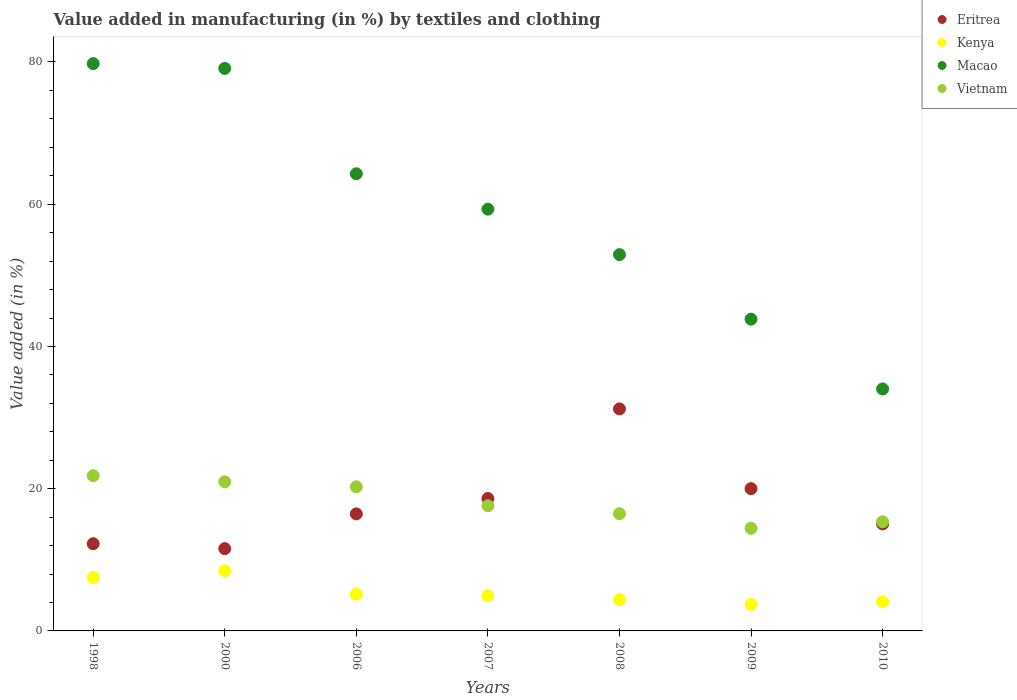How many different coloured dotlines are there?
Offer a terse response. 4. Is the number of dotlines equal to the number of legend labels?
Provide a succinct answer. Yes. What is the percentage of value added in manufacturing by textiles and clothing in Kenya in 2008?
Give a very brief answer. 4.4. Across all years, what is the maximum percentage of value added in manufacturing by textiles and clothing in Eritrea?
Give a very brief answer. 31.22. Across all years, what is the minimum percentage of value added in manufacturing by textiles and clothing in Macao?
Provide a short and direct response. 34.02. In which year was the percentage of value added in manufacturing by textiles and clothing in Vietnam maximum?
Your answer should be very brief. 1998. In which year was the percentage of value added in manufacturing by textiles and clothing in Kenya minimum?
Keep it short and to the point. 2009. What is the total percentage of value added in manufacturing by textiles and clothing in Kenya in the graph?
Your answer should be compact. 38.33. What is the difference between the percentage of value added in manufacturing by textiles and clothing in Eritrea in 2006 and that in 2007?
Your response must be concise. -2.16. What is the difference between the percentage of value added in manufacturing by textiles and clothing in Vietnam in 2006 and the percentage of value added in manufacturing by textiles and clothing in Macao in 2009?
Offer a terse response. -23.58. What is the average percentage of value added in manufacturing by textiles and clothing in Kenya per year?
Ensure brevity in your answer.  5.48. In the year 2008, what is the difference between the percentage of value added in manufacturing by textiles and clothing in Kenya and percentage of value added in manufacturing by textiles and clothing in Vietnam?
Offer a terse response. -12.08. In how many years, is the percentage of value added in manufacturing by textiles and clothing in Eritrea greater than 60 %?
Provide a short and direct response. 0. What is the ratio of the percentage of value added in manufacturing by textiles and clothing in Vietnam in 2000 to that in 2006?
Give a very brief answer. 1.03. Is the percentage of value added in manufacturing by textiles and clothing in Eritrea in 2006 less than that in 2008?
Provide a succinct answer. Yes. Is the difference between the percentage of value added in manufacturing by textiles and clothing in Kenya in 1998 and 2009 greater than the difference between the percentage of value added in manufacturing by textiles and clothing in Vietnam in 1998 and 2009?
Offer a very short reply. No. What is the difference between the highest and the second highest percentage of value added in manufacturing by textiles and clothing in Kenya?
Your answer should be compact. 0.94. What is the difference between the highest and the lowest percentage of value added in manufacturing by textiles and clothing in Macao?
Ensure brevity in your answer.  45.75. In how many years, is the percentage of value added in manufacturing by textiles and clothing in Eritrea greater than the average percentage of value added in manufacturing by textiles and clothing in Eritrea taken over all years?
Make the answer very short. 3. Is it the case that in every year, the sum of the percentage of value added in manufacturing by textiles and clothing in Vietnam and percentage of value added in manufacturing by textiles and clothing in Kenya  is greater than the sum of percentage of value added in manufacturing by textiles and clothing in Macao and percentage of value added in manufacturing by textiles and clothing in Eritrea?
Make the answer very short. No. Is it the case that in every year, the sum of the percentage of value added in manufacturing by textiles and clothing in Eritrea and percentage of value added in manufacturing by textiles and clothing in Macao  is greater than the percentage of value added in manufacturing by textiles and clothing in Vietnam?
Your response must be concise. Yes. How many dotlines are there?
Give a very brief answer. 4. How many legend labels are there?
Offer a terse response. 4. How are the legend labels stacked?
Offer a very short reply. Vertical. What is the title of the graph?
Ensure brevity in your answer.  Value added in manufacturing (in %) by textiles and clothing. Does "Germany" appear as one of the legend labels in the graph?
Ensure brevity in your answer.  No. What is the label or title of the X-axis?
Your answer should be very brief. Years. What is the label or title of the Y-axis?
Offer a very short reply. Value added (in %). What is the Value added (in %) of Eritrea in 1998?
Keep it short and to the point. 12.26. What is the Value added (in %) in Kenya in 1998?
Make the answer very short. 7.53. What is the Value added (in %) in Macao in 1998?
Provide a succinct answer. 79.77. What is the Value added (in %) of Vietnam in 1998?
Your answer should be compact. 21.83. What is the Value added (in %) in Eritrea in 2000?
Offer a terse response. 11.57. What is the Value added (in %) of Kenya in 2000?
Ensure brevity in your answer.  8.47. What is the Value added (in %) in Macao in 2000?
Offer a very short reply. 79.1. What is the Value added (in %) in Vietnam in 2000?
Ensure brevity in your answer.  20.96. What is the Value added (in %) of Eritrea in 2006?
Your answer should be compact. 16.46. What is the Value added (in %) in Kenya in 2006?
Your answer should be very brief. 5.18. What is the Value added (in %) in Macao in 2006?
Offer a very short reply. 64.28. What is the Value added (in %) in Vietnam in 2006?
Offer a terse response. 20.26. What is the Value added (in %) of Eritrea in 2007?
Offer a terse response. 18.62. What is the Value added (in %) in Kenya in 2007?
Provide a succinct answer. 4.93. What is the Value added (in %) in Macao in 2007?
Give a very brief answer. 59.3. What is the Value added (in %) in Vietnam in 2007?
Make the answer very short. 17.59. What is the Value added (in %) in Eritrea in 2008?
Provide a short and direct response. 31.22. What is the Value added (in %) in Kenya in 2008?
Your response must be concise. 4.4. What is the Value added (in %) of Macao in 2008?
Offer a very short reply. 52.92. What is the Value added (in %) in Vietnam in 2008?
Give a very brief answer. 16.48. What is the Value added (in %) of Eritrea in 2009?
Offer a very short reply. 20.01. What is the Value added (in %) of Kenya in 2009?
Give a very brief answer. 3.72. What is the Value added (in %) of Macao in 2009?
Ensure brevity in your answer.  43.84. What is the Value added (in %) of Vietnam in 2009?
Provide a succinct answer. 14.43. What is the Value added (in %) in Eritrea in 2010?
Provide a succinct answer. 15.04. What is the Value added (in %) in Kenya in 2010?
Provide a succinct answer. 4.1. What is the Value added (in %) of Macao in 2010?
Provide a succinct answer. 34.02. What is the Value added (in %) of Vietnam in 2010?
Provide a short and direct response. 15.35. Across all years, what is the maximum Value added (in %) of Eritrea?
Give a very brief answer. 31.22. Across all years, what is the maximum Value added (in %) in Kenya?
Make the answer very short. 8.47. Across all years, what is the maximum Value added (in %) in Macao?
Your answer should be compact. 79.77. Across all years, what is the maximum Value added (in %) in Vietnam?
Give a very brief answer. 21.83. Across all years, what is the minimum Value added (in %) in Eritrea?
Your answer should be very brief. 11.57. Across all years, what is the minimum Value added (in %) in Kenya?
Offer a very short reply. 3.72. Across all years, what is the minimum Value added (in %) in Macao?
Your answer should be very brief. 34.02. Across all years, what is the minimum Value added (in %) of Vietnam?
Offer a very short reply. 14.43. What is the total Value added (in %) in Eritrea in the graph?
Give a very brief answer. 125.17. What is the total Value added (in %) in Kenya in the graph?
Keep it short and to the point. 38.33. What is the total Value added (in %) of Macao in the graph?
Make the answer very short. 413.23. What is the total Value added (in %) in Vietnam in the graph?
Provide a succinct answer. 126.9. What is the difference between the Value added (in %) of Eritrea in 1998 and that in 2000?
Give a very brief answer. 0.69. What is the difference between the Value added (in %) of Kenya in 1998 and that in 2000?
Your answer should be compact. -0.94. What is the difference between the Value added (in %) of Macao in 1998 and that in 2000?
Keep it short and to the point. 0.67. What is the difference between the Value added (in %) in Vietnam in 1998 and that in 2000?
Your answer should be compact. 0.86. What is the difference between the Value added (in %) in Eritrea in 1998 and that in 2006?
Give a very brief answer. -4.19. What is the difference between the Value added (in %) in Kenya in 1998 and that in 2006?
Your answer should be compact. 2.35. What is the difference between the Value added (in %) in Macao in 1998 and that in 2006?
Offer a terse response. 15.49. What is the difference between the Value added (in %) of Vietnam in 1998 and that in 2006?
Ensure brevity in your answer.  1.57. What is the difference between the Value added (in %) in Eritrea in 1998 and that in 2007?
Ensure brevity in your answer.  -6.36. What is the difference between the Value added (in %) of Kenya in 1998 and that in 2007?
Keep it short and to the point. 2.6. What is the difference between the Value added (in %) in Macao in 1998 and that in 2007?
Offer a terse response. 20.47. What is the difference between the Value added (in %) in Vietnam in 1998 and that in 2007?
Provide a succinct answer. 4.23. What is the difference between the Value added (in %) of Eritrea in 1998 and that in 2008?
Provide a short and direct response. -18.95. What is the difference between the Value added (in %) of Kenya in 1998 and that in 2008?
Provide a succinct answer. 3.13. What is the difference between the Value added (in %) in Macao in 1998 and that in 2008?
Provide a short and direct response. 26.86. What is the difference between the Value added (in %) of Vietnam in 1998 and that in 2008?
Provide a short and direct response. 5.34. What is the difference between the Value added (in %) of Eritrea in 1998 and that in 2009?
Your answer should be compact. -7.74. What is the difference between the Value added (in %) of Kenya in 1998 and that in 2009?
Provide a short and direct response. 3.81. What is the difference between the Value added (in %) of Macao in 1998 and that in 2009?
Your answer should be very brief. 35.93. What is the difference between the Value added (in %) in Vietnam in 1998 and that in 2009?
Ensure brevity in your answer.  7.4. What is the difference between the Value added (in %) in Eritrea in 1998 and that in 2010?
Provide a succinct answer. -2.78. What is the difference between the Value added (in %) in Kenya in 1998 and that in 2010?
Your response must be concise. 3.43. What is the difference between the Value added (in %) of Macao in 1998 and that in 2010?
Your answer should be compact. 45.75. What is the difference between the Value added (in %) in Vietnam in 1998 and that in 2010?
Your answer should be compact. 6.48. What is the difference between the Value added (in %) in Eritrea in 2000 and that in 2006?
Make the answer very short. -4.89. What is the difference between the Value added (in %) of Kenya in 2000 and that in 2006?
Provide a succinct answer. 3.29. What is the difference between the Value added (in %) of Macao in 2000 and that in 2006?
Make the answer very short. 14.82. What is the difference between the Value added (in %) in Vietnam in 2000 and that in 2006?
Ensure brevity in your answer.  0.7. What is the difference between the Value added (in %) in Eritrea in 2000 and that in 2007?
Your answer should be very brief. -7.05. What is the difference between the Value added (in %) in Kenya in 2000 and that in 2007?
Offer a terse response. 3.53. What is the difference between the Value added (in %) of Macao in 2000 and that in 2007?
Your answer should be compact. 19.79. What is the difference between the Value added (in %) in Vietnam in 2000 and that in 2007?
Your answer should be compact. 3.37. What is the difference between the Value added (in %) of Eritrea in 2000 and that in 2008?
Make the answer very short. -19.65. What is the difference between the Value added (in %) of Kenya in 2000 and that in 2008?
Your answer should be compact. 4.06. What is the difference between the Value added (in %) of Macao in 2000 and that in 2008?
Give a very brief answer. 26.18. What is the difference between the Value added (in %) in Vietnam in 2000 and that in 2008?
Ensure brevity in your answer.  4.48. What is the difference between the Value added (in %) of Eritrea in 2000 and that in 2009?
Give a very brief answer. -8.44. What is the difference between the Value added (in %) in Kenya in 2000 and that in 2009?
Your answer should be very brief. 4.74. What is the difference between the Value added (in %) of Macao in 2000 and that in 2009?
Your response must be concise. 35.26. What is the difference between the Value added (in %) of Vietnam in 2000 and that in 2009?
Offer a very short reply. 6.54. What is the difference between the Value added (in %) in Eritrea in 2000 and that in 2010?
Your answer should be very brief. -3.47. What is the difference between the Value added (in %) in Kenya in 2000 and that in 2010?
Provide a short and direct response. 4.36. What is the difference between the Value added (in %) in Macao in 2000 and that in 2010?
Give a very brief answer. 45.07. What is the difference between the Value added (in %) in Vietnam in 2000 and that in 2010?
Offer a terse response. 5.61. What is the difference between the Value added (in %) of Eritrea in 2006 and that in 2007?
Make the answer very short. -2.16. What is the difference between the Value added (in %) of Kenya in 2006 and that in 2007?
Your answer should be very brief. 0.24. What is the difference between the Value added (in %) in Macao in 2006 and that in 2007?
Your answer should be very brief. 4.98. What is the difference between the Value added (in %) in Vietnam in 2006 and that in 2007?
Keep it short and to the point. 2.67. What is the difference between the Value added (in %) in Eritrea in 2006 and that in 2008?
Your answer should be compact. -14.76. What is the difference between the Value added (in %) in Kenya in 2006 and that in 2008?
Offer a very short reply. 0.77. What is the difference between the Value added (in %) in Macao in 2006 and that in 2008?
Provide a short and direct response. 11.37. What is the difference between the Value added (in %) in Vietnam in 2006 and that in 2008?
Provide a succinct answer. 3.78. What is the difference between the Value added (in %) of Eritrea in 2006 and that in 2009?
Your answer should be compact. -3.55. What is the difference between the Value added (in %) of Kenya in 2006 and that in 2009?
Your answer should be very brief. 1.45. What is the difference between the Value added (in %) in Macao in 2006 and that in 2009?
Keep it short and to the point. 20.44. What is the difference between the Value added (in %) in Vietnam in 2006 and that in 2009?
Keep it short and to the point. 5.83. What is the difference between the Value added (in %) of Eritrea in 2006 and that in 2010?
Make the answer very short. 1.41. What is the difference between the Value added (in %) of Kenya in 2006 and that in 2010?
Your answer should be compact. 1.07. What is the difference between the Value added (in %) in Macao in 2006 and that in 2010?
Offer a terse response. 30.26. What is the difference between the Value added (in %) in Vietnam in 2006 and that in 2010?
Offer a very short reply. 4.91. What is the difference between the Value added (in %) of Eritrea in 2007 and that in 2008?
Provide a succinct answer. -12.6. What is the difference between the Value added (in %) of Kenya in 2007 and that in 2008?
Offer a very short reply. 0.53. What is the difference between the Value added (in %) of Macao in 2007 and that in 2008?
Your answer should be compact. 6.39. What is the difference between the Value added (in %) in Vietnam in 2007 and that in 2008?
Give a very brief answer. 1.11. What is the difference between the Value added (in %) in Eritrea in 2007 and that in 2009?
Offer a terse response. -1.39. What is the difference between the Value added (in %) of Kenya in 2007 and that in 2009?
Ensure brevity in your answer.  1.21. What is the difference between the Value added (in %) in Macao in 2007 and that in 2009?
Provide a succinct answer. 15.47. What is the difference between the Value added (in %) in Vietnam in 2007 and that in 2009?
Provide a succinct answer. 3.17. What is the difference between the Value added (in %) of Eritrea in 2007 and that in 2010?
Your response must be concise. 3.57. What is the difference between the Value added (in %) of Kenya in 2007 and that in 2010?
Your answer should be compact. 0.83. What is the difference between the Value added (in %) in Macao in 2007 and that in 2010?
Your response must be concise. 25.28. What is the difference between the Value added (in %) in Vietnam in 2007 and that in 2010?
Your answer should be very brief. 2.24. What is the difference between the Value added (in %) of Eritrea in 2008 and that in 2009?
Make the answer very short. 11.21. What is the difference between the Value added (in %) of Kenya in 2008 and that in 2009?
Your response must be concise. 0.68. What is the difference between the Value added (in %) of Macao in 2008 and that in 2009?
Give a very brief answer. 9.08. What is the difference between the Value added (in %) in Vietnam in 2008 and that in 2009?
Ensure brevity in your answer.  2.06. What is the difference between the Value added (in %) of Eritrea in 2008 and that in 2010?
Your response must be concise. 16.17. What is the difference between the Value added (in %) in Kenya in 2008 and that in 2010?
Ensure brevity in your answer.  0.3. What is the difference between the Value added (in %) of Macao in 2008 and that in 2010?
Ensure brevity in your answer.  18.89. What is the difference between the Value added (in %) of Vietnam in 2008 and that in 2010?
Give a very brief answer. 1.13. What is the difference between the Value added (in %) of Eritrea in 2009 and that in 2010?
Ensure brevity in your answer.  4.96. What is the difference between the Value added (in %) of Kenya in 2009 and that in 2010?
Give a very brief answer. -0.38. What is the difference between the Value added (in %) in Macao in 2009 and that in 2010?
Provide a short and direct response. 9.82. What is the difference between the Value added (in %) in Vietnam in 2009 and that in 2010?
Give a very brief answer. -0.92. What is the difference between the Value added (in %) of Eritrea in 1998 and the Value added (in %) of Kenya in 2000?
Your answer should be very brief. 3.8. What is the difference between the Value added (in %) of Eritrea in 1998 and the Value added (in %) of Macao in 2000?
Offer a terse response. -66.84. What is the difference between the Value added (in %) of Eritrea in 1998 and the Value added (in %) of Vietnam in 2000?
Your answer should be compact. -8.7. What is the difference between the Value added (in %) of Kenya in 1998 and the Value added (in %) of Macao in 2000?
Ensure brevity in your answer.  -71.57. What is the difference between the Value added (in %) in Kenya in 1998 and the Value added (in %) in Vietnam in 2000?
Ensure brevity in your answer.  -13.43. What is the difference between the Value added (in %) of Macao in 1998 and the Value added (in %) of Vietnam in 2000?
Provide a short and direct response. 58.81. What is the difference between the Value added (in %) in Eritrea in 1998 and the Value added (in %) in Kenya in 2006?
Offer a terse response. 7.09. What is the difference between the Value added (in %) of Eritrea in 1998 and the Value added (in %) of Macao in 2006?
Offer a very short reply. -52.02. What is the difference between the Value added (in %) in Eritrea in 1998 and the Value added (in %) in Vietnam in 2006?
Your answer should be compact. -8. What is the difference between the Value added (in %) of Kenya in 1998 and the Value added (in %) of Macao in 2006?
Ensure brevity in your answer.  -56.75. What is the difference between the Value added (in %) of Kenya in 1998 and the Value added (in %) of Vietnam in 2006?
Offer a terse response. -12.73. What is the difference between the Value added (in %) of Macao in 1998 and the Value added (in %) of Vietnam in 2006?
Provide a succinct answer. 59.51. What is the difference between the Value added (in %) in Eritrea in 1998 and the Value added (in %) in Kenya in 2007?
Give a very brief answer. 7.33. What is the difference between the Value added (in %) in Eritrea in 1998 and the Value added (in %) in Macao in 2007?
Offer a very short reply. -47.04. What is the difference between the Value added (in %) of Eritrea in 1998 and the Value added (in %) of Vietnam in 2007?
Your answer should be compact. -5.33. What is the difference between the Value added (in %) of Kenya in 1998 and the Value added (in %) of Macao in 2007?
Keep it short and to the point. -51.78. What is the difference between the Value added (in %) in Kenya in 1998 and the Value added (in %) in Vietnam in 2007?
Provide a succinct answer. -10.06. What is the difference between the Value added (in %) of Macao in 1998 and the Value added (in %) of Vietnam in 2007?
Offer a very short reply. 62.18. What is the difference between the Value added (in %) of Eritrea in 1998 and the Value added (in %) of Kenya in 2008?
Make the answer very short. 7.86. What is the difference between the Value added (in %) of Eritrea in 1998 and the Value added (in %) of Macao in 2008?
Your answer should be compact. -40.65. What is the difference between the Value added (in %) in Eritrea in 1998 and the Value added (in %) in Vietnam in 2008?
Give a very brief answer. -4.22. What is the difference between the Value added (in %) of Kenya in 1998 and the Value added (in %) of Macao in 2008?
Your answer should be very brief. -45.39. What is the difference between the Value added (in %) of Kenya in 1998 and the Value added (in %) of Vietnam in 2008?
Ensure brevity in your answer.  -8.95. What is the difference between the Value added (in %) in Macao in 1998 and the Value added (in %) in Vietnam in 2008?
Your response must be concise. 63.29. What is the difference between the Value added (in %) of Eritrea in 1998 and the Value added (in %) of Kenya in 2009?
Your answer should be very brief. 8.54. What is the difference between the Value added (in %) in Eritrea in 1998 and the Value added (in %) in Macao in 2009?
Ensure brevity in your answer.  -31.58. What is the difference between the Value added (in %) of Eritrea in 1998 and the Value added (in %) of Vietnam in 2009?
Ensure brevity in your answer.  -2.16. What is the difference between the Value added (in %) of Kenya in 1998 and the Value added (in %) of Macao in 2009?
Make the answer very short. -36.31. What is the difference between the Value added (in %) of Kenya in 1998 and the Value added (in %) of Vietnam in 2009?
Provide a succinct answer. -6.9. What is the difference between the Value added (in %) in Macao in 1998 and the Value added (in %) in Vietnam in 2009?
Your answer should be compact. 65.34. What is the difference between the Value added (in %) of Eritrea in 1998 and the Value added (in %) of Kenya in 2010?
Make the answer very short. 8.16. What is the difference between the Value added (in %) of Eritrea in 1998 and the Value added (in %) of Macao in 2010?
Give a very brief answer. -21.76. What is the difference between the Value added (in %) in Eritrea in 1998 and the Value added (in %) in Vietnam in 2010?
Your answer should be very brief. -3.09. What is the difference between the Value added (in %) in Kenya in 1998 and the Value added (in %) in Macao in 2010?
Ensure brevity in your answer.  -26.5. What is the difference between the Value added (in %) in Kenya in 1998 and the Value added (in %) in Vietnam in 2010?
Offer a terse response. -7.82. What is the difference between the Value added (in %) in Macao in 1998 and the Value added (in %) in Vietnam in 2010?
Ensure brevity in your answer.  64.42. What is the difference between the Value added (in %) in Eritrea in 2000 and the Value added (in %) in Kenya in 2006?
Your response must be concise. 6.39. What is the difference between the Value added (in %) of Eritrea in 2000 and the Value added (in %) of Macao in 2006?
Your answer should be compact. -52.71. What is the difference between the Value added (in %) of Eritrea in 2000 and the Value added (in %) of Vietnam in 2006?
Offer a terse response. -8.69. What is the difference between the Value added (in %) in Kenya in 2000 and the Value added (in %) in Macao in 2006?
Offer a very short reply. -55.82. What is the difference between the Value added (in %) in Kenya in 2000 and the Value added (in %) in Vietnam in 2006?
Your response must be concise. -11.79. What is the difference between the Value added (in %) in Macao in 2000 and the Value added (in %) in Vietnam in 2006?
Ensure brevity in your answer.  58.84. What is the difference between the Value added (in %) in Eritrea in 2000 and the Value added (in %) in Kenya in 2007?
Give a very brief answer. 6.64. What is the difference between the Value added (in %) of Eritrea in 2000 and the Value added (in %) of Macao in 2007?
Your answer should be compact. -47.74. What is the difference between the Value added (in %) of Eritrea in 2000 and the Value added (in %) of Vietnam in 2007?
Make the answer very short. -6.02. What is the difference between the Value added (in %) in Kenya in 2000 and the Value added (in %) in Macao in 2007?
Offer a very short reply. -50.84. What is the difference between the Value added (in %) of Kenya in 2000 and the Value added (in %) of Vietnam in 2007?
Provide a succinct answer. -9.13. What is the difference between the Value added (in %) of Macao in 2000 and the Value added (in %) of Vietnam in 2007?
Keep it short and to the point. 61.51. What is the difference between the Value added (in %) of Eritrea in 2000 and the Value added (in %) of Kenya in 2008?
Give a very brief answer. 7.17. What is the difference between the Value added (in %) of Eritrea in 2000 and the Value added (in %) of Macao in 2008?
Offer a very short reply. -41.35. What is the difference between the Value added (in %) in Eritrea in 2000 and the Value added (in %) in Vietnam in 2008?
Provide a short and direct response. -4.91. What is the difference between the Value added (in %) of Kenya in 2000 and the Value added (in %) of Macao in 2008?
Give a very brief answer. -44.45. What is the difference between the Value added (in %) of Kenya in 2000 and the Value added (in %) of Vietnam in 2008?
Keep it short and to the point. -8.02. What is the difference between the Value added (in %) in Macao in 2000 and the Value added (in %) in Vietnam in 2008?
Your answer should be very brief. 62.62. What is the difference between the Value added (in %) of Eritrea in 2000 and the Value added (in %) of Kenya in 2009?
Provide a short and direct response. 7.85. What is the difference between the Value added (in %) in Eritrea in 2000 and the Value added (in %) in Macao in 2009?
Provide a succinct answer. -32.27. What is the difference between the Value added (in %) in Eritrea in 2000 and the Value added (in %) in Vietnam in 2009?
Keep it short and to the point. -2.86. What is the difference between the Value added (in %) of Kenya in 2000 and the Value added (in %) of Macao in 2009?
Your response must be concise. -35.37. What is the difference between the Value added (in %) in Kenya in 2000 and the Value added (in %) in Vietnam in 2009?
Provide a short and direct response. -5.96. What is the difference between the Value added (in %) of Macao in 2000 and the Value added (in %) of Vietnam in 2009?
Ensure brevity in your answer.  64.67. What is the difference between the Value added (in %) of Eritrea in 2000 and the Value added (in %) of Kenya in 2010?
Provide a short and direct response. 7.47. What is the difference between the Value added (in %) in Eritrea in 2000 and the Value added (in %) in Macao in 2010?
Ensure brevity in your answer.  -22.45. What is the difference between the Value added (in %) in Eritrea in 2000 and the Value added (in %) in Vietnam in 2010?
Ensure brevity in your answer.  -3.78. What is the difference between the Value added (in %) of Kenya in 2000 and the Value added (in %) of Macao in 2010?
Ensure brevity in your answer.  -25.56. What is the difference between the Value added (in %) of Kenya in 2000 and the Value added (in %) of Vietnam in 2010?
Offer a terse response. -6.88. What is the difference between the Value added (in %) in Macao in 2000 and the Value added (in %) in Vietnam in 2010?
Ensure brevity in your answer.  63.75. What is the difference between the Value added (in %) of Eritrea in 2006 and the Value added (in %) of Kenya in 2007?
Offer a very short reply. 11.52. What is the difference between the Value added (in %) in Eritrea in 2006 and the Value added (in %) in Macao in 2007?
Offer a very short reply. -42.85. What is the difference between the Value added (in %) in Eritrea in 2006 and the Value added (in %) in Vietnam in 2007?
Keep it short and to the point. -1.14. What is the difference between the Value added (in %) of Kenya in 2006 and the Value added (in %) of Macao in 2007?
Provide a succinct answer. -54.13. What is the difference between the Value added (in %) of Kenya in 2006 and the Value added (in %) of Vietnam in 2007?
Make the answer very short. -12.42. What is the difference between the Value added (in %) of Macao in 2006 and the Value added (in %) of Vietnam in 2007?
Your answer should be compact. 46.69. What is the difference between the Value added (in %) in Eritrea in 2006 and the Value added (in %) in Kenya in 2008?
Provide a succinct answer. 12.05. What is the difference between the Value added (in %) of Eritrea in 2006 and the Value added (in %) of Macao in 2008?
Your response must be concise. -36.46. What is the difference between the Value added (in %) of Eritrea in 2006 and the Value added (in %) of Vietnam in 2008?
Provide a succinct answer. -0.03. What is the difference between the Value added (in %) in Kenya in 2006 and the Value added (in %) in Macao in 2008?
Give a very brief answer. -47.74. What is the difference between the Value added (in %) in Kenya in 2006 and the Value added (in %) in Vietnam in 2008?
Give a very brief answer. -11.31. What is the difference between the Value added (in %) in Macao in 2006 and the Value added (in %) in Vietnam in 2008?
Provide a short and direct response. 47.8. What is the difference between the Value added (in %) of Eritrea in 2006 and the Value added (in %) of Kenya in 2009?
Your response must be concise. 12.73. What is the difference between the Value added (in %) in Eritrea in 2006 and the Value added (in %) in Macao in 2009?
Offer a very short reply. -27.38. What is the difference between the Value added (in %) in Eritrea in 2006 and the Value added (in %) in Vietnam in 2009?
Your response must be concise. 2.03. What is the difference between the Value added (in %) in Kenya in 2006 and the Value added (in %) in Macao in 2009?
Your answer should be very brief. -38.66. What is the difference between the Value added (in %) of Kenya in 2006 and the Value added (in %) of Vietnam in 2009?
Your response must be concise. -9.25. What is the difference between the Value added (in %) of Macao in 2006 and the Value added (in %) of Vietnam in 2009?
Your answer should be compact. 49.86. What is the difference between the Value added (in %) of Eritrea in 2006 and the Value added (in %) of Kenya in 2010?
Ensure brevity in your answer.  12.35. What is the difference between the Value added (in %) of Eritrea in 2006 and the Value added (in %) of Macao in 2010?
Provide a short and direct response. -17.57. What is the difference between the Value added (in %) in Eritrea in 2006 and the Value added (in %) in Vietnam in 2010?
Keep it short and to the point. 1.11. What is the difference between the Value added (in %) in Kenya in 2006 and the Value added (in %) in Macao in 2010?
Your answer should be compact. -28.85. What is the difference between the Value added (in %) of Kenya in 2006 and the Value added (in %) of Vietnam in 2010?
Provide a succinct answer. -10.17. What is the difference between the Value added (in %) of Macao in 2006 and the Value added (in %) of Vietnam in 2010?
Provide a succinct answer. 48.93. What is the difference between the Value added (in %) in Eritrea in 2007 and the Value added (in %) in Kenya in 2008?
Make the answer very short. 14.22. What is the difference between the Value added (in %) of Eritrea in 2007 and the Value added (in %) of Macao in 2008?
Provide a succinct answer. -34.3. What is the difference between the Value added (in %) of Eritrea in 2007 and the Value added (in %) of Vietnam in 2008?
Your answer should be compact. 2.14. What is the difference between the Value added (in %) in Kenya in 2007 and the Value added (in %) in Macao in 2008?
Your answer should be compact. -47.98. What is the difference between the Value added (in %) of Kenya in 2007 and the Value added (in %) of Vietnam in 2008?
Make the answer very short. -11.55. What is the difference between the Value added (in %) of Macao in 2007 and the Value added (in %) of Vietnam in 2008?
Keep it short and to the point. 42.82. What is the difference between the Value added (in %) of Eritrea in 2007 and the Value added (in %) of Kenya in 2009?
Give a very brief answer. 14.89. What is the difference between the Value added (in %) in Eritrea in 2007 and the Value added (in %) in Macao in 2009?
Offer a terse response. -25.22. What is the difference between the Value added (in %) of Eritrea in 2007 and the Value added (in %) of Vietnam in 2009?
Keep it short and to the point. 4.19. What is the difference between the Value added (in %) of Kenya in 2007 and the Value added (in %) of Macao in 2009?
Give a very brief answer. -38.91. What is the difference between the Value added (in %) in Kenya in 2007 and the Value added (in %) in Vietnam in 2009?
Offer a very short reply. -9.49. What is the difference between the Value added (in %) in Macao in 2007 and the Value added (in %) in Vietnam in 2009?
Keep it short and to the point. 44.88. What is the difference between the Value added (in %) of Eritrea in 2007 and the Value added (in %) of Kenya in 2010?
Give a very brief answer. 14.52. What is the difference between the Value added (in %) in Eritrea in 2007 and the Value added (in %) in Macao in 2010?
Make the answer very short. -15.41. What is the difference between the Value added (in %) in Eritrea in 2007 and the Value added (in %) in Vietnam in 2010?
Your answer should be compact. 3.27. What is the difference between the Value added (in %) in Kenya in 2007 and the Value added (in %) in Macao in 2010?
Your response must be concise. -29.09. What is the difference between the Value added (in %) in Kenya in 2007 and the Value added (in %) in Vietnam in 2010?
Give a very brief answer. -10.42. What is the difference between the Value added (in %) of Macao in 2007 and the Value added (in %) of Vietnam in 2010?
Your response must be concise. 43.95. What is the difference between the Value added (in %) in Eritrea in 2008 and the Value added (in %) in Kenya in 2009?
Provide a short and direct response. 27.49. What is the difference between the Value added (in %) of Eritrea in 2008 and the Value added (in %) of Macao in 2009?
Your response must be concise. -12.62. What is the difference between the Value added (in %) of Eritrea in 2008 and the Value added (in %) of Vietnam in 2009?
Offer a very short reply. 16.79. What is the difference between the Value added (in %) of Kenya in 2008 and the Value added (in %) of Macao in 2009?
Your answer should be very brief. -39.44. What is the difference between the Value added (in %) of Kenya in 2008 and the Value added (in %) of Vietnam in 2009?
Offer a very short reply. -10.03. What is the difference between the Value added (in %) in Macao in 2008 and the Value added (in %) in Vietnam in 2009?
Ensure brevity in your answer.  38.49. What is the difference between the Value added (in %) in Eritrea in 2008 and the Value added (in %) in Kenya in 2010?
Offer a terse response. 27.11. What is the difference between the Value added (in %) of Eritrea in 2008 and the Value added (in %) of Macao in 2010?
Provide a succinct answer. -2.81. What is the difference between the Value added (in %) of Eritrea in 2008 and the Value added (in %) of Vietnam in 2010?
Offer a terse response. 15.87. What is the difference between the Value added (in %) of Kenya in 2008 and the Value added (in %) of Macao in 2010?
Your response must be concise. -29.62. What is the difference between the Value added (in %) of Kenya in 2008 and the Value added (in %) of Vietnam in 2010?
Provide a succinct answer. -10.95. What is the difference between the Value added (in %) in Macao in 2008 and the Value added (in %) in Vietnam in 2010?
Ensure brevity in your answer.  37.57. What is the difference between the Value added (in %) in Eritrea in 2009 and the Value added (in %) in Kenya in 2010?
Offer a very short reply. 15.91. What is the difference between the Value added (in %) of Eritrea in 2009 and the Value added (in %) of Macao in 2010?
Provide a short and direct response. -14.02. What is the difference between the Value added (in %) of Eritrea in 2009 and the Value added (in %) of Vietnam in 2010?
Offer a very short reply. 4.66. What is the difference between the Value added (in %) in Kenya in 2009 and the Value added (in %) in Macao in 2010?
Your answer should be compact. -30.3. What is the difference between the Value added (in %) of Kenya in 2009 and the Value added (in %) of Vietnam in 2010?
Offer a very short reply. -11.63. What is the difference between the Value added (in %) in Macao in 2009 and the Value added (in %) in Vietnam in 2010?
Your response must be concise. 28.49. What is the average Value added (in %) of Eritrea per year?
Offer a very short reply. 17.88. What is the average Value added (in %) of Kenya per year?
Make the answer very short. 5.48. What is the average Value added (in %) of Macao per year?
Give a very brief answer. 59.03. What is the average Value added (in %) of Vietnam per year?
Ensure brevity in your answer.  18.13. In the year 1998, what is the difference between the Value added (in %) in Eritrea and Value added (in %) in Kenya?
Your answer should be very brief. 4.73. In the year 1998, what is the difference between the Value added (in %) of Eritrea and Value added (in %) of Macao?
Ensure brevity in your answer.  -67.51. In the year 1998, what is the difference between the Value added (in %) in Eritrea and Value added (in %) in Vietnam?
Provide a short and direct response. -9.57. In the year 1998, what is the difference between the Value added (in %) of Kenya and Value added (in %) of Macao?
Provide a succinct answer. -72.24. In the year 1998, what is the difference between the Value added (in %) in Kenya and Value added (in %) in Vietnam?
Provide a short and direct response. -14.3. In the year 1998, what is the difference between the Value added (in %) in Macao and Value added (in %) in Vietnam?
Make the answer very short. 57.94. In the year 2000, what is the difference between the Value added (in %) in Eritrea and Value added (in %) in Kenya?
Your answer should be compact. 3.1. In the year 2000, what is the difference between the Value added (in %) in Eritrea and Value added (in %) in Macao?
Your answer should be very brief. -67.53. In the year 2000, what is the difference between the Value added (in %) in Eritrea and Value added (in %) in Vietnam?
Your response must be concise. -9.39. In the year 2000, what is the difference between the Value added (in %) of Kenya and Value added (in %) of Macao?
Your answer should be compact. -70.63. In the year 2000, what is the difference between the Value added (in %) in Kenya and Value added (in %) in Vietnam?
Provide a succinct answer. -12.5. In the year 2000, what is the difference between the Value added (in %) of Macao and Value added (in %) of Vietnam?
Give a very brief answer. 58.14. In the year 2006, what is the difference between the Value added (in %) in Eritrea and Value added (in %) in Kenya?
Provide a short and direct response. 11.28. In the year 2006, what is the difference between the Value added (in %) in Eritrea and Value added (in %) in Macao?
Your answer should be very brief. -47.83. In the year 2006, what is the difference between the Value added (in %) in Eritrea and Value added (in %) in Vietnam?
Offer a very short reply. -3.8. In the year 2006, what is the difference between the Value added (in %) of Kenya and Value added (in %) of Macao?
Provide a succinct answer. -59.11. In the year 2006, what is the difference between the Value added (in %) in Kenya and Value added (in %) in Vietnam?
Offer a very short reply. -15.08. In the year 2006, what is the difference between the Value added (in %) of Macao and Value added (in %) of Vietnam?
Your answer should be very brief. 44.02. In the year 2007, what is the difference between the Value added (in %) in Eritrea and Value added (in %) in Kenya?
Keep it short and to the point. 13.69. In the year 2007, what is the difference between the Value added (in %) in Eritrea and Value added (in %) in Macao?
Ensure brevity in your answer.  -40.69. In the year 2007, what is the difference between the Value added (in %) of Eritrea and Value added (in %) of Vietnam?
Keep it short and to the point. 1.02. In the year 2007, what is the difference between the Value added (in %) in Kenya and Value added (in %) in Macao?
Your answer should be very brief. -54.37. In the year 2007, what is the difference between the Value added (in %) in Kenya and Value added (in %) in Vietnam?
Provide a short and direct response. -12.66. In the year 2007, what is the difference between the Value added (in %) of Macao and Value added (in %) of Vietnam?
Offer a terse response. 41.71. In the year 2008, what is the difference between the Value added (in %) in Eritrea and Value added (in %) in Kenya?
Offer a very short reply. 26.82. In the year 2008, what is the difference between the Value added (in %) in Eritrea and Value added (in %) in Macao?
Give a very brief answer. -21.7. In the year 2008, what is the difference between the Value added (in %) of Eritrea and Value added (in %) of Vietnam?
Offer a terse response. 14.73. In the year 2008, what is the difference between the Value added (in %) of Kenya and Value added (in %) of Macao?
Your answer should be very brief. -48.51. In the year 2008, what is the difference between the Value added (in %) in Kenya and Value added (in %) in Vietnam?
Provide a succinct answer. -12.08. In the year 2008, what is the difference between the Value added (in %) of Macao and Value added (in %) of Vietnam?
Your answer should be compact. 36.43. In the year 2009, what is the difference between the Value added (in %) in Eritrea and Value added (in %) in Kenya?
Make the answer very short. 16.28. In the year 2009, what is the difference between the Value added (in %) in Eritrea and Value added (in %) in Macao?
Your answer should be compact. -23.83. In the year 2009, what is the difference between the Value added (in %) of Eritrea and Value added (in %) of Vietnam?
Ensure brevity in your answer.  5.58. In the year 2009, what is the difference between the Value added (in %) in Kenya and Value added (in %) in Macao?
Your response must be concise. -40.12. In the year 2009, what is the difference between the Value added (in %) of Kenya and Value added (in %) of Vietnam?
Provide a succinct answer. -10.7. In the year 2009, what is the difference between the Value added (in %) of Macao and Value added (in %) of Vietnam?
Your response must be concise. 29.41. In the year 2010, what is the difference between the Value added (in %) of Eritrea and Value added (in %) of Kenya?
Provide a short and direct response. 10.94. In the year 2010, what is the difference between the Value added (in %) in Eritrea and Value added (in %) in Macao?
Your answer should be compact. -18.98. In the year 2010, what is the difference between the Value added (in %) in Eritrea and Value added (in %) in Vietnam?
Your response must be concise. -0.31. In the year 2010, what is the difference between the Value added (in %) in Kenya and Value added (in %) in Macao?
Make the answer very short. -29.92. In the year 2010, what is the difference between the Value added (in %) in Kenya and Value added (in %) in Vietnam?
Offer a very short reply. -11.25. In the year 2010, what is the difference between the Value added (in %) in Macao and Value added (in %) in Vietnam?
Give a very brief answer. 18.67. What is the ratio of the Value added (in %) in Eritrea in 1998 to that in 2000?
Your answer should be compact. 1.06. What is the ratio of the Value added (in %) of Kenya in 1998 to that in 2000?
Provide a succinct answer. 0.89. What is the ratio of the Value added (in %) of Macao in 1998 to that in 2000?
Ensure brevity in your answer.  1.01. What is the ratio of the Value added (in %) of Vietnam in 1998 to that in 2000?
Your answer should be very brief. 1.04. What is the ratio of the Value added (in %) in Eritrea in 1998 to that in 2006?
Provide a short and direct response. 0.75. What is the ratio of the Value added (in %) of Kenya in 1998 to that in 2006?
Your answer should be very brief. 1.45. What is the ratio of the Value added (in %) in Macao in 1998 to that in 2006?
Your answer should be very brief. 1.24. What is the ratio of the Value added (in %) in Vietnam in 1998 to that in 2006?
Give a very brief answer. 1.08. What is the ratio of the Value added (in %) in Eritrea in 1998 to that in 2007?
Offer a very short reply. 0.66. What is the ratio of the Value added (in %) of Kenya in 1998 to that in 2007?
Provide a short and direct response. 1.53. What is the ratio of the Value added (in %) in Macao in 1998 to that in 2007?
Offer a very short reply. 1.35. What is the ratio of the Value added (in %) of Vietnam in 1998 to that in 2007?
Your answer should be compact. 1.24. What is the ratio of the Value added (in %) in Eritrea in 1998 to that in 2008?
Your answer should be very brief. 0.39. What is the ratio of the Value added (in %) in Kenya in 1998 to that in 2008?
Keep it short and to the point. 1.71. What is the ratio of the Value added (in %) in Macao in 1998 to that in 2008?
Offer a terse response. 1.51. What is the ratio of the Value added (in %) in Vietnam in 1998 to that in 2008?
Give a very brief answer. 1.32. What is the ratio of the Value added (in %) of Eritrea in 1998 to that in 2009?
Give a very brief answer. 0.61. What is the ratio of the Value added (in %) of Kenya in 1998 to that in 2009?
Make the answer very short. 2.02. What is the ratio of the Value added (in %) of Macao in 1998 to that in 2009?
Your response must be concise. 1.82. What is the ratio of the Value added (in %) of Vietnam in 1998 to that in 2009?
Your answer should be very brief. 1.51. What is the ratio of the Value added (in %) in Eritrea in 1998 to that in 2010?
Your response must be concise. 0.82. What is the ratio of the Value added (in %) of Kenya in 1998 to that in 2010?
Keep it short and to the point. 1.84. What is the ratio of the Value added (in %) in Macao in 1998 to that in 2010?
Your answer should be compact. 2.34. What is the ratio of the Value added (in %) in Vietnam in 1998 to that in 2010?
Provide a short and direct response. 1.42. What is the ratio of the Value added (in %) of Eritrea in 2000 to that in 2006?
Offer a terse response. 0.7. What is the ratio of the Value added (in %) in Kenya in 2000 to that in 2006?
Offer a terse response. 1.64. What is the ratio of the Value added (in %) in Macao in 2000 to that in 2006?
Your answer should be very brief. 1.23. What is the ratio of the Value added (in %) of Vietnam in 2000 to that in 2006?
Provide a succinct answer. 1.03. What is the ratio of the Value added (in %) of Eritrea in 2000 to that in 2007?
Your response must be concise. 0.62. What is the ratio of the Value added (in %) in Kenya in 2000 to that in 2007?
Provide a short and direct response. 1.72. What is the ratio of the Value added (in %) of Macao in 2000 to that in 2007?
Your answer should be compact. 1.33. What is the ratio of the Value added (in %) of Vietnam in 2000 to that in 2007?
Your response must be concise. 1.19. What is the ratio of the Value added (in %) in Eritrea in 2000 to that in 2008?
Make the answer very short. 0.37. What is the ratio of the Value added (in %) of Kenya in 2000 to that in 2008?
Keep it short and to the point. 1.92. What is the ratio of the Value added (in %) in Macao in 2000 to that in 2008?
Give a very brief answer. 1.49. What is the ratio of the Value added (in %) in Vietnam in 2000 to that in 2008?
Make the answer very short. 1.27. What is the ratio of the Value added (in %) in Eritrea in 2000 to that in 2009?
Your answer should be very brief. 0.58. What is the ratio of the Value added (in %) of Kenya in 2000 to that in 2009?
Your answer should be compact. 2.27. What is the ratio of the Value added (in %) of Macao in 2000 to that in 2009?
Keep it short and to the point. 1.8. What is the ratio of the Value added (in %) in Vietnam in 2000 to that in 2009?
Keep it short and to the point. 1.45. What is the ratio of the Value added (in %) in Eritrea in 2000 to that in 2010?
Provide a succinct answer. 0.77. What is the ratio of the Value added (in %) of Kenya in 2000 to that in 2010?
Provide a short and direct response. 2.06. What is the ratio of the Value added (in %) of Macao in 2000 to that in 2010?
Offer a very short reply. 2.32. What is the ratio of the Value added (in %) of Vietnam in 2000 to that in 2010?
Offer a very short reply. 1.37. What is the ratio of the Value added (in %) of Eritrea in 2006 to that in 2007?
Provide a succinct answer. 0.88. What is the ratio of the Value added (in %) in Kenya in 2006 to that in 2007?
Your answer should be compact. 1.05. What is the ratio of the Value added (in %) of Macao in 2006 to that in 2007?
Keep it short and to the point. 1.08. What is the ratio of the Value added (in %) in Vietnam in 2006 to that in 2007?
Give a very brief answer. 1.15. What is the ratio of the Value added (in %) in Eritrea in 2006 to that in 2008?
Give a very brief answer. 0.53. What is the ratio of the Value added (in %) of Kenya in 2006 to that in 2008?
Provide a short and direct response. 1.18. What is the ratio of the Value added (in %) in Macao in 2006 to that in 2008?
Offer a terse response. 1.21. What is the ratio of the Value added (in %) in Vietnam in 2006 to that in 2008?
Keep it short and to the point. 1.23. What is the ratio of the Value added (in %) in Eritrea in 2006 to that in 2009?
Provide a succinct answer. 0.82. What is the ratio of the Value added (in %) of Kenya in 2006 to that in 2009?
Your response must be concise. 1.39. What is the ratio of the Value added (in %) in Macao in 2006 to that in 2009?
Provide a short and direct response. 1.47. What is the ratio of the Value added (in %) of Vietnam in 2006 to that in 2009?
Offer a terse response. 1.4. What is the ratio of the Value added (in %) in Eritrea in 2006 to that in 2010?
Make the answer very short. 1.09. What is the ratio of the Value added (in %) in Kenya in 2006 to that in 2010?
Make the answer very short. 1.26. What is the ratio of the Value added (in %) of Macao in 2006 to that in 2010?
Offer a very short reply. 1.89. What is the ratio of the Value added (in %) in Vietnam in 2006 to that in 2010?
Your response must be concise. 1.32. What is the ratio of the Value added (in %) in Eritrea in 2007 to that in 2008?
Ensure brevity in your answer.  0.6. What is the ratio of the Value added (in %) of Kenya in 2007 to that in 2008?
Your answer should be very brief. 1.12. What is the ratio of the Value added (in %) of Macao in 2007 to that in 2008?
Ensure brevity in your answer.  1.12. What is the ratio of the Value added (in %) of Vietnam in 2007 to that in 2008?
Provide a succinct answer. 1.07. What is the ratio of the Value added (in %) of Eritrea in 2007 to that in 2009?
Give a very brief answer. 0.93. What is the ratio of the Value added (in %) in Kenya in 2007 to that in 2009?
Your response must be concise. 1.32. What is the ratio of the Value added (in %) in Macao in 2007 to that in 2009?
Provide a short and direct response. 1.35. What is the ratio of the Value added (in %) of Vietnam in 2007 to that in 2009?
Offer a very short reply. 1.22. What is the ratio of the Value added (in %) of Eritrea in 2007 to that in 2010?
Your answer should be very brief. 1.24. What is the ratio of the Value added (in %) in Kenya in 2007 to that in 2010?
Your answer should be compact. 1.2. What is the ratio of the Value added (in %) in Macao in 2007 to that in 2010?
Ensure brevity in your answer.  1.74. What is the ratio of the Value added (in %) of Vietnam in 2007 to that in 2010?
Your response must be concise. 1.15. What is the ratio of the Value added (in %) in Eritrea in 2008 to that in 2009?
Provide a short and direct response. 1.56. What is the ratio of the Value added (in %) in Kenya in 2008 to that in 2009?
Offer a very short reply. 1.18. What is the ratio of the Value added (in %) in Macao in 2008 to that in 2009?
Offer a terse response. 1.21. What is the ratio of the Value added (in %) of Vietnam in 2008 to that in 2009?
Offer a terse response. 1.14. What is the ratio of the Value added (in %) in Eritrea in 2008 to that in 2010?
Provide a succinct answer. 2.08. What is the ratio of the Value added (in %) of Kenya in 2008 to that in 2010?
Your answer should be very brief. 1.07. What is the ratio of the Value added (in %) in Macao in 2008 to that in 2010?
Offer a terse response. 1.56. What is the ratio of the Value added (in %) in Vietnam in 2008 to that in 2010?
Offer a very short reply. 1.07. What is the ratio of the Value added (in %) of Eritrea in 2009 to that in 2010?
Your response must be concise. 1.33. What is the ratio of the Value added (in %) of Kenya in 2009 to that in 2010?
Your answer should be very brief. 0.91. What is the ratio of the Value added (in %) of Macao in 2009 to that in 2010?
Your answer should be very brief. 1.29. What is the ratio of the Value added (in %) in Vietnam in 2009 to that in 2010?
Keep it short and to the point. 0.94. What is the difference between the highest and the second highest Value added (in %) in Eritrea?
Make the answer very short. 11.21. What is the difference between the highest and the second highest Value added (in %) of Kenya?
Provide a succinct answer. 0.94. What is the difference between the highest and the second highest Value added (in %) in Macao?
Keep it short and to the point. 0.67. What is the difference between the highest and the second highest Value added (in %) in Vietnam?
Provide a succinct answer. 0.86. What is the difference between the highest and the lowest Value added (in %) in Eritrea?
Provide a short and direct response. 19.65. What is the difference between the highest and the lowest Value added (in %) of Kenya?
Give a very brief answer. 4.74. What is the difference between the highest and the lowest Value added (in %) in Macao?
Your response must be concise. 45.75. What is the difference between the highest and the lowest Value added (in %) of Vietnam?
Give a very brief answer. 7.4. 